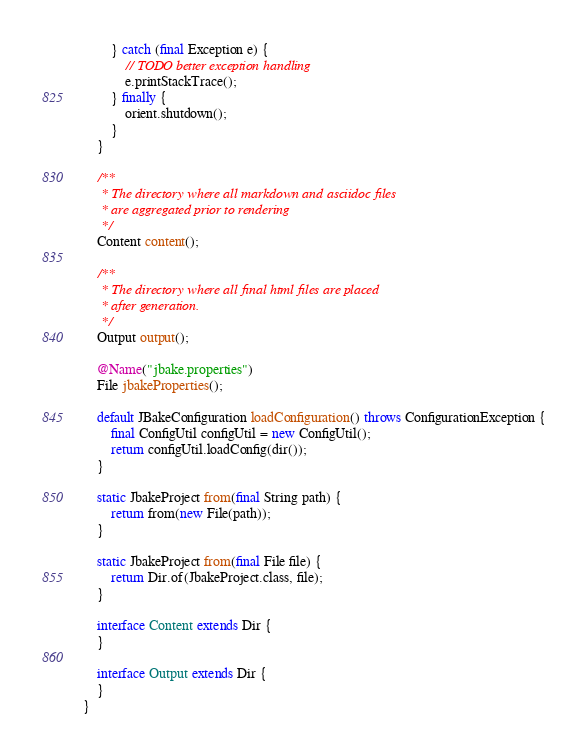<code> <loc_0><loc_0><loc_500><loc_500><_Java_>        } catch (final Exception e) {
            // TODO better exception handling
            e.printStackTrace();
        } finally {
            orient.shutdown();
        }
    }

    /**
     * The directory where all markdown and asciidoc files
     * are aggregated prior to rendering
     */
    Content content();

    /**
     * The directory where all final html files are placed
     * after generation.
     */
    Output output();

    @Name("jbake.properties")
    File jbakeProperties();

    default JBakeConfiguration loadConfiguration() throws ConfigurationException {
        final ConfigUtil configUtil = new ConfigUtil();
        return configUtil.loadConfig(dir());
    }

    static JbakeProject from(final String path) {
        return from(new File(path));
    }

    static JbakeProject from(final File file) {
        return Dir.of(JbakeProject.class, file);
    }

    interface Content extends Dir {
    }

    interface Output extends Dir {
    }
}
</code> 